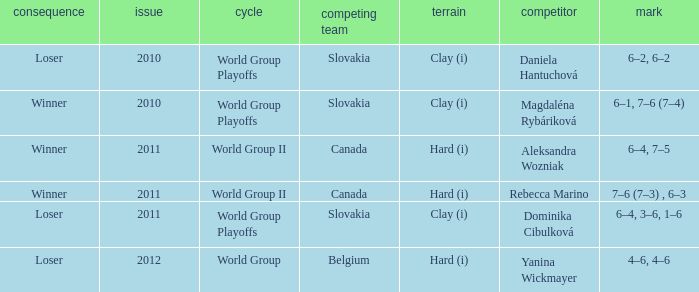How many outcomes were there when the opponent was Aleksandra Wozniak? 1.0. 